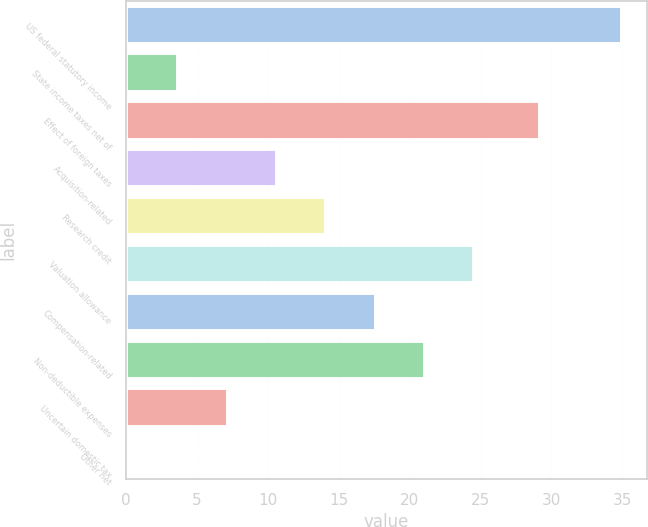Convert chart. <chart><loc_0><loc_0><loc_500><loc_500><bar_chart><fcel>US federal statutory income<fcel>State income taxes net of<fcel>Effect of foreign taxes<fcel>Acquisition-related<fcel>Research credit<fcel>Valuation allowance<fcel>Compensation-related<fcel>Non-deductible expenses<fcel>Uncertain domestic tax<fcel>Other net<nl><fcel>35<fcel>3.68<fcel>29.2<fcel>10.64<fcel>14.12<fcel>24.56<fcel>17.6<fcel>21.08<fcel>7.16<fcel>0.2<nl></chart> 